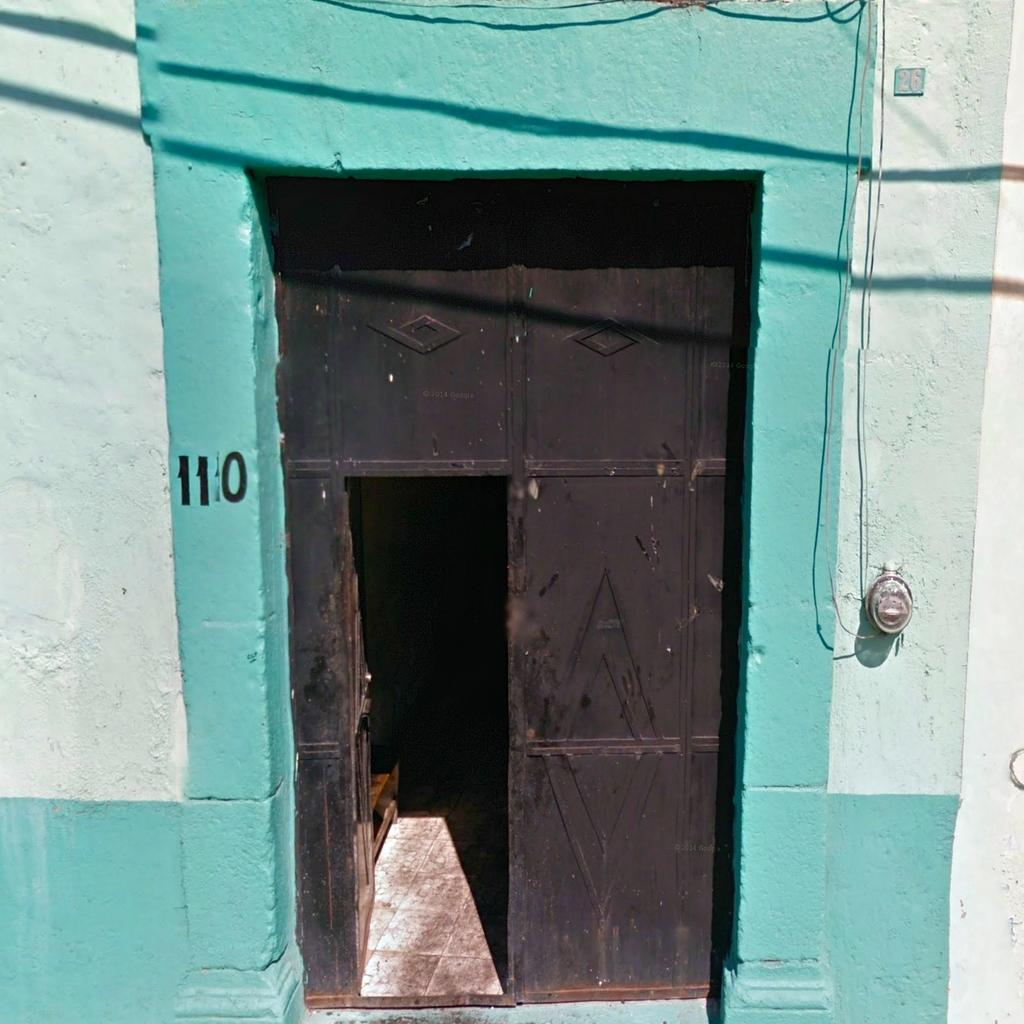What type of structure is present in the image? There is a building in the image. What colors are used on the building? The building has white and green colors. Is there any entrance to the building visible in the image? Yes, there is a gate in front of the building. What is the color of the gate? The gate is black in color. What type of prose can be seen on the building's walls in the image? There is no prose visible on the building's walls in the image. How many pets are present in the image? There are no pets present in the image. 